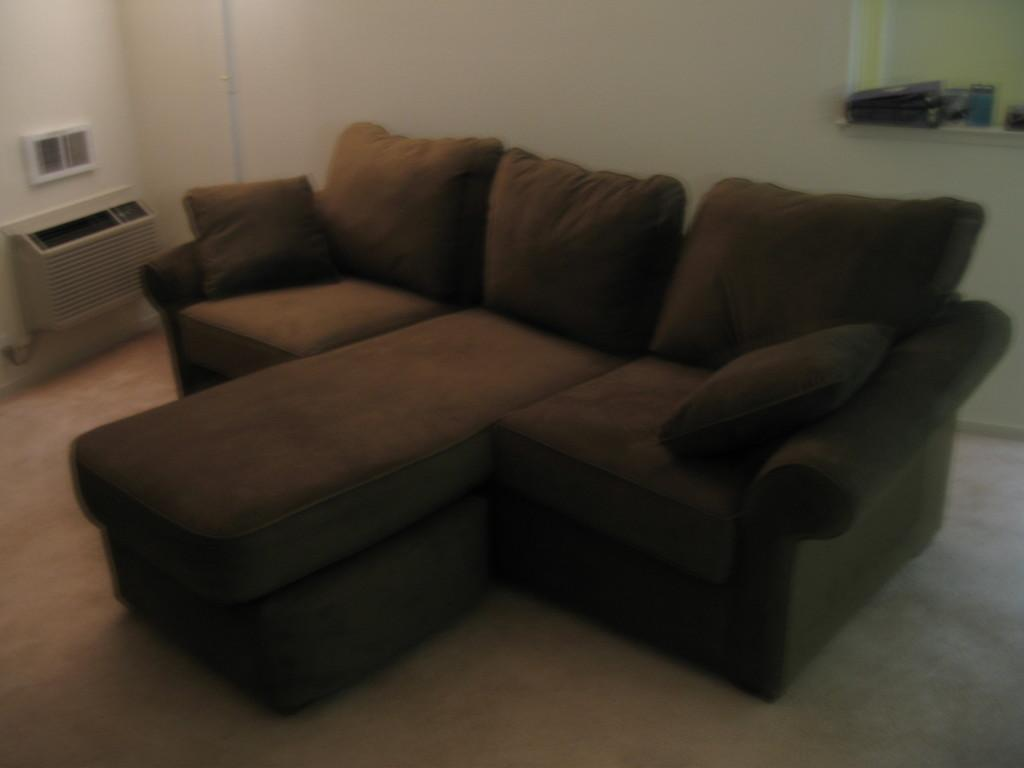What color are the sofas in the image? The sofas in the image are brown colored. What color is the wall in the image? The wall in the image is white. How does the wrist affect the night in the image? There is no mention of a wrist or night in the image, so this question cannot be answered. 